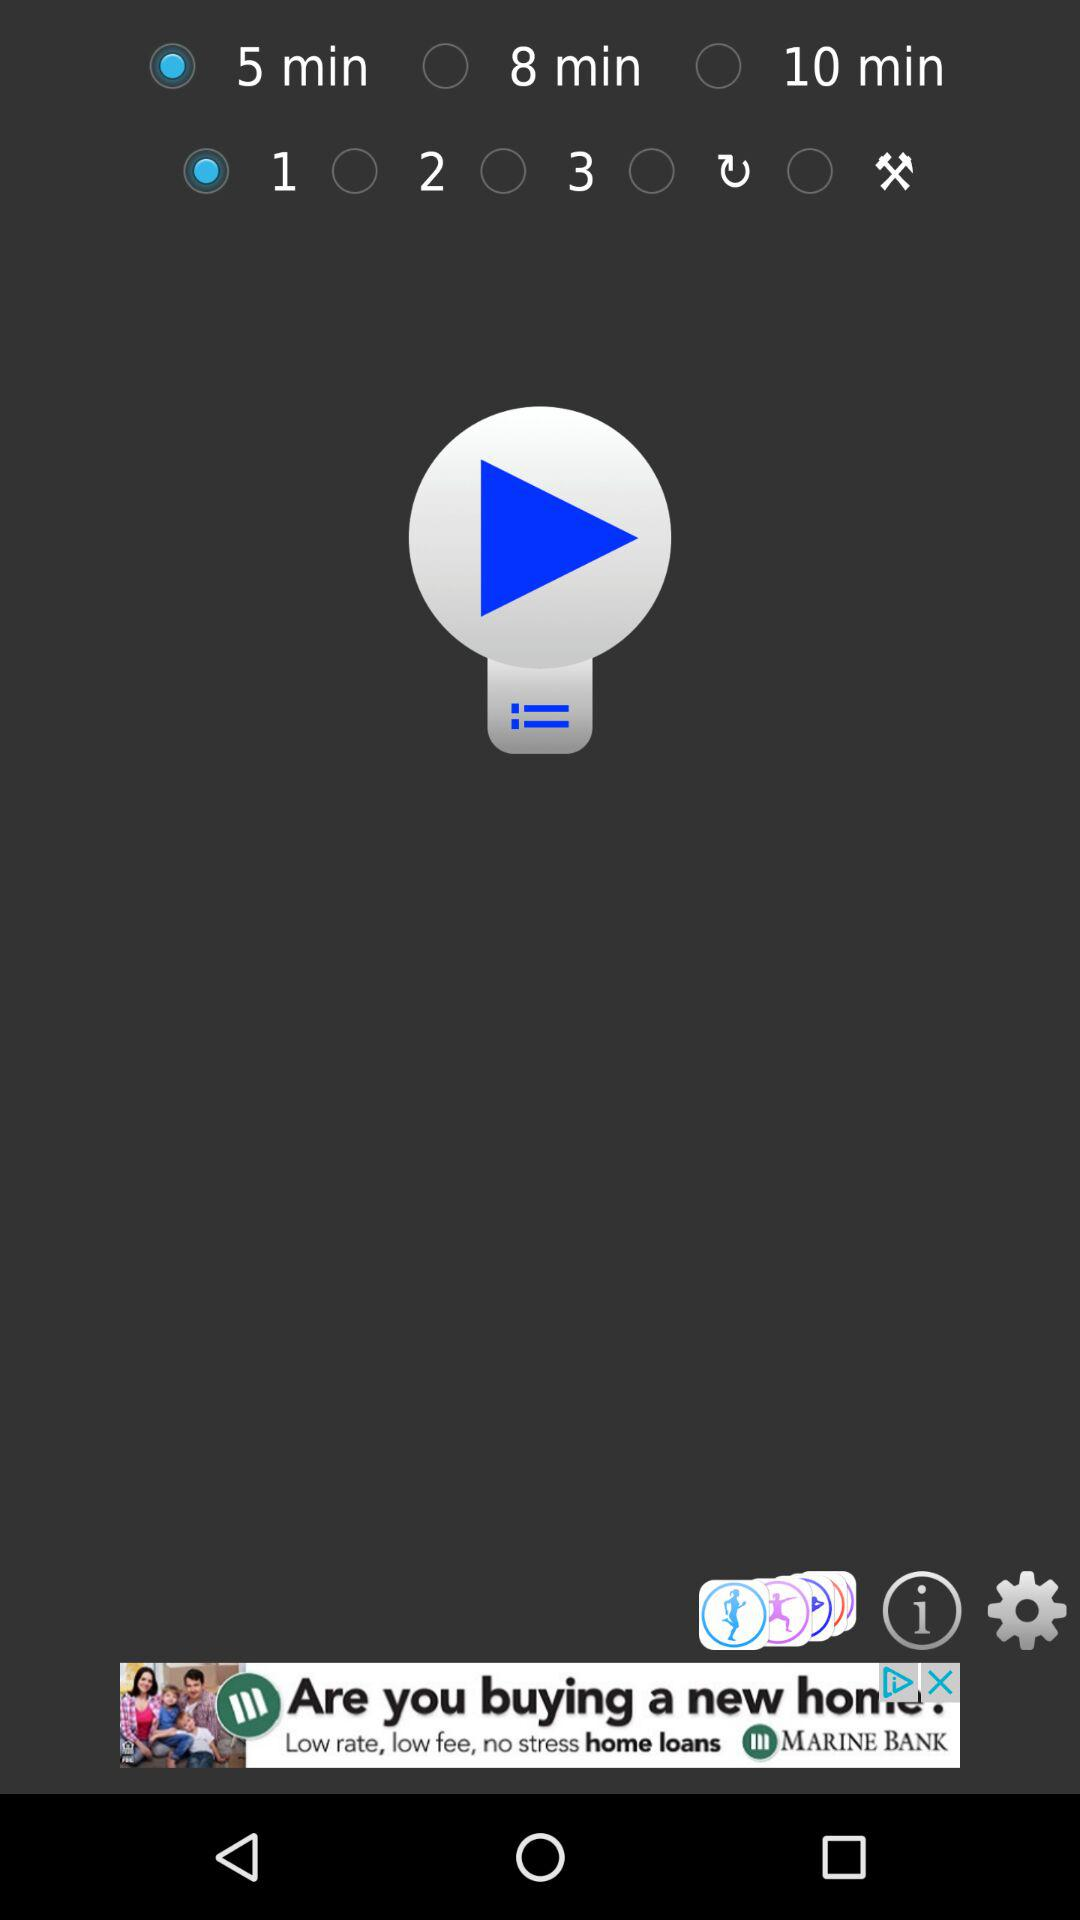What is the status of "5 min"? The status is "on". 